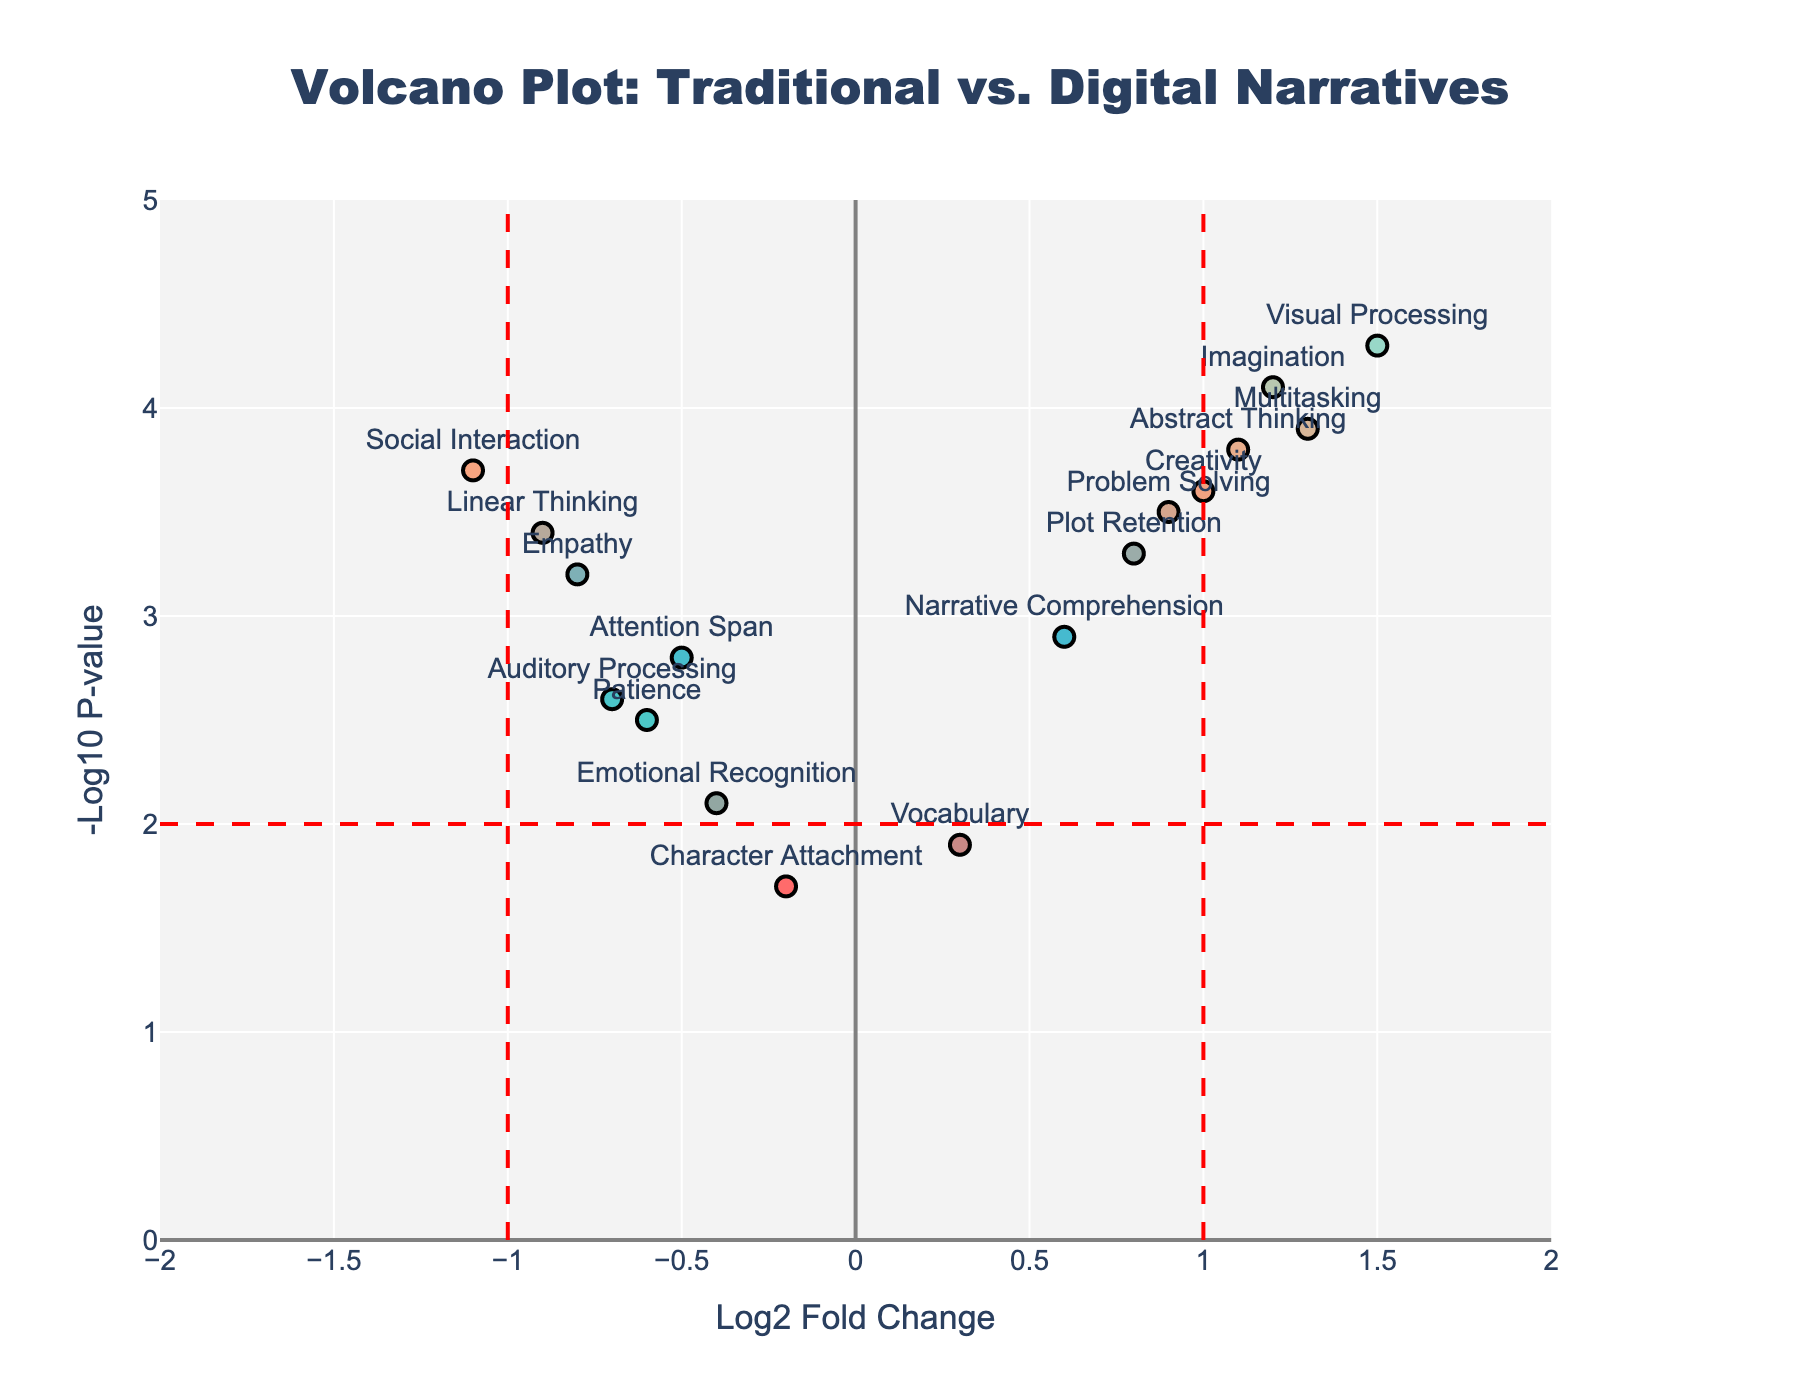What is the title of the figure? The title is typically found at the top of the figure and is used to summarize what the figure is about.
Answer: Volcano Plot: Traditional vs. Digital Narratives What are the labels of the x and y axes? The x and y axis labels provide information on what each axis represents. Read the labels next to each axis.
Answer: Log2 Fold Change (x-axis), -Log10 P-value (y-axis) How many data points are there in the figure? Count the number of marks or data points presented in the plot.
Answer: 16 Which data point has the highest -Log10 p-value? Locate the data point that appears highest on the y-axis. The label next to this point will provide the name.
Answer: Visual Processing Which data point has the lowest Log2 Fold Change? Look at the data points on the far left of the x-axis and identify the closest one to this side.
Answer: Social Interaction How many data points have a Log2 Fold Change greater than 1? Inspect and count the number of data points to the right of the vertical line at Log2 Fold Change = 1.
Answer: 4 Which data points have both a Log2 Fold Change greater than 0 and a -Log10 P-value greater than 2? Identify the points located in the quadrant where both the x and y values are greater than these thresholds.
Answer: Imagination, Problem Solving, Visual Processing, Narrative Comprehension, Plot Retention, Multitasking, Abstract Thinking, Creativity Between Empathy and Imagination, which has a higher -Log10 p-value and by how much? Locate both data points, compare their y-axis values, and calculate the difference.
Answer: Imagination is higher by 0.9 Are there more data points with negative Log2 Fold Changes or positive Log2 Fold Changes? Count the number of points to the left (negative) and to the right (positive) of the vertical line at Log2 Fold Change = 0.
Answer: More positive (9 vs. 7) What does the vertical dashed red line at Log2 Fold Change = 1 represent? This line typically highlights a threshold of interest and separates more significant changes from less significant ones based on the fold change.
Answer: Threshold for significant positive change 